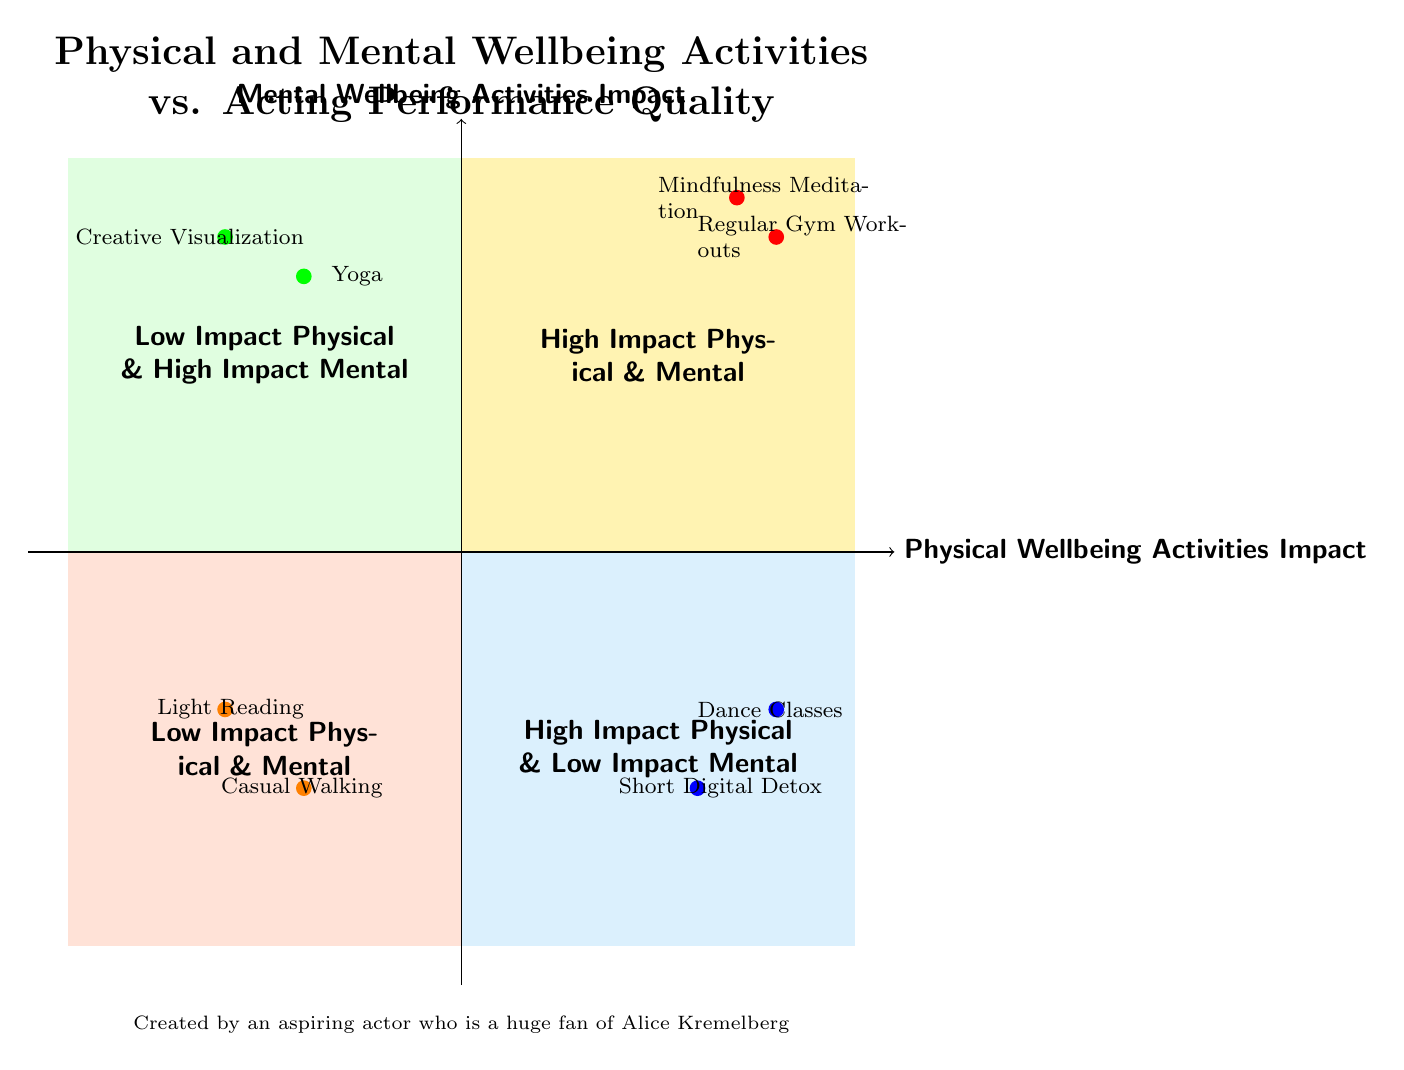What activities are in the "High Impact Physical & High Impact Mental" quadrant? The quadrant labeled "High Impact Physical & High Impact Mental" contains "Regular Gym Workouts" and "Mindfulness Meditation." These activities are listed within that section of the diagram.
Answer: Regular Gym Workouts and Mindfulness Meditation How many activities are listed in the "Low Impact Physical & Low Impact Mental" quadrant? In the "Low Impact Physical & Low Impact Mental" quadrant, there are two activities: "Casual Walking" and "Light Reading." By counting the listed activities, the total is found to be two.
Answer: 2 Which activity has a high impact on mental wellbeing but low impact on physical wellbeing? The "Yoga" activity aligns with the criteria of having high impact on mental wellbeing while having low impact on physical wellbeing, as indicated in the respective quadrant.
Answer: Yoga What is the main focus of the "High Impact Physical & Low Impact Mental" quadrant? This quadrant emphasizes activities that enhance physical fitness but do not significantly contribute to mental wellbeing. It includes "Dance Classes" and "Short Digital Detox," reflecting the focus.
Answer: Physical fitness Which quadrant includes "Creative Visualization"? "Creative Visualization" is located in the "Low Impact Physical & High Impact Mental" quadrant, as shown in the diagram by the quadrant's description and activities it contains.
Answer: Low Impact Physical & High Impact Mental Which activity is described as allowing for body movement precision? The "Dance Classes" activity in the "High Impact Physical & Low Impact Mental" quadrant is explicitly described as enhancing body movement precision and expressiveness for roles that require it.
Answer: Dance Classes What is the primary purpose of "Mindfulness Meditation"? The description notes that "Mindfulness Meditation" aims to help practitioners stay grounded and composed, allowing them to more effectively tap into emotional depth for acting scenes.
Answer: Stay grounded and composed List the activities that have a "High Impact" specifically on physical wellbeing. The listed activities that have a "High Impact" on physical wellbeing include "Regular Gym Workouts" and "Dance Classes." Both activities are positioned in quadrants pertaining to high physical impact.
Answer: Regular Gym Workouts and Dance Classes How is the impact described of "Light Reading" on acting performance? "Light Reading" is described as having minimal influence on preparing for complex acting roles, indicating that its impact is quite low for that purpose.
Answer: Minimal influence 